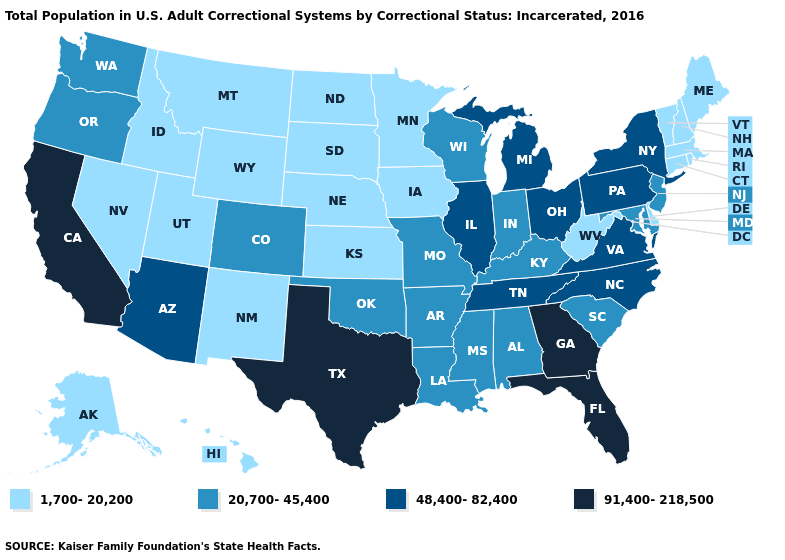Which states have the lowest value in the USA?
Answer briefly. Alaska, Connecticut, Delaware, Hawaii, Idaho, Iowa, Kansas, Maine, Massachusetts, Minnesota, Montana, Nebraska, Nevada, New Hampshire, New Mexico, North Dakota, Rhode Island, South Dakota, Utah, Vermont, West Virginia, Wyoming. Which states have the lowest value in the USA?
Write a very short answer. Alaska, Connecticut, Delaware, Hawaii, Idaho, Iowa, Kansas, Maine, Massachusetts, Minnesota, Montana, Nebraska, Nevada, New Hampshire, New Mexico, North Dakota, Rhode Island, South Dakota, Utah, Vermont, West Virginia, Wyoming. Name the states that have a value in the range 20,700-45,400?
Give a very brief answer. Alabama, Arkansas, Colorado, Indiana, Kentucky, Louisiana, Maryland, Mississippi, Missouri, New Jersey, Oklahoma, Oregon, South Carolina, Washington, Wisconsin. Name the states that have a value in the range 48,400-82,400?
Be succinct. Arizona, Illinois, Michigan, New York, North Carolina, Ohio, Pennsylvania, Tennessee, Virginia. Does Ohio have the lowest value in the USA?
Quick response, please. No. What is the lowest value in the USA?
Write a very short answer. 1,700-20,200. Among the states that border South Dakota , which have the lowest value?
Quick response, please. Iowa, Minnesota, Montana, Nebraska, North Dakota, Wyoming. Does the first symbol in the legend represent the smallest category?
Answer briefly. Yes. Among the states that border New Jersey , which have the lowest value?
Be succinct. Delaware. Which states have the lowest value in the USA?
Give a very brief answer. Alaska, Connecticut, Delaware, Hawaii, Idaho, Iowa, Kansas, Maine, Massachusetts, Minnesota, Montana, Nebraska, Nevada, New Hampshire, New Mexico, North Dakota, Rhode Island, South Dakota, Utah, Vermont, West Virginia, Wyoming. Name the states that have a value in the range 48,400-82,400?
Answer briefly. Arizona, Illinois, Michigan, New York, North Carolina, Ohio, Pennsylvania, Tennessee, Virginia. What is the value of Massachusetts?
Quick response, please. 1,700-20,200. What is the value of South Carolina?
Concise answer only. 20,700-45,400. Does Florida have the highest value in the USA?
Concise answer only. Yes. 